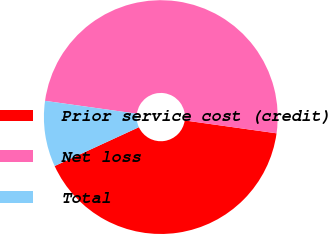Convert chart. <chart><loc_0><loc_0><loc_500><loc_500><pie_chart><fcel>Prior service cost (credit)<fcel>Net loss<fcel>Total<nl><fcel>40.91%<fcel>50.0%<fcel>9.09%<nl></chart> 